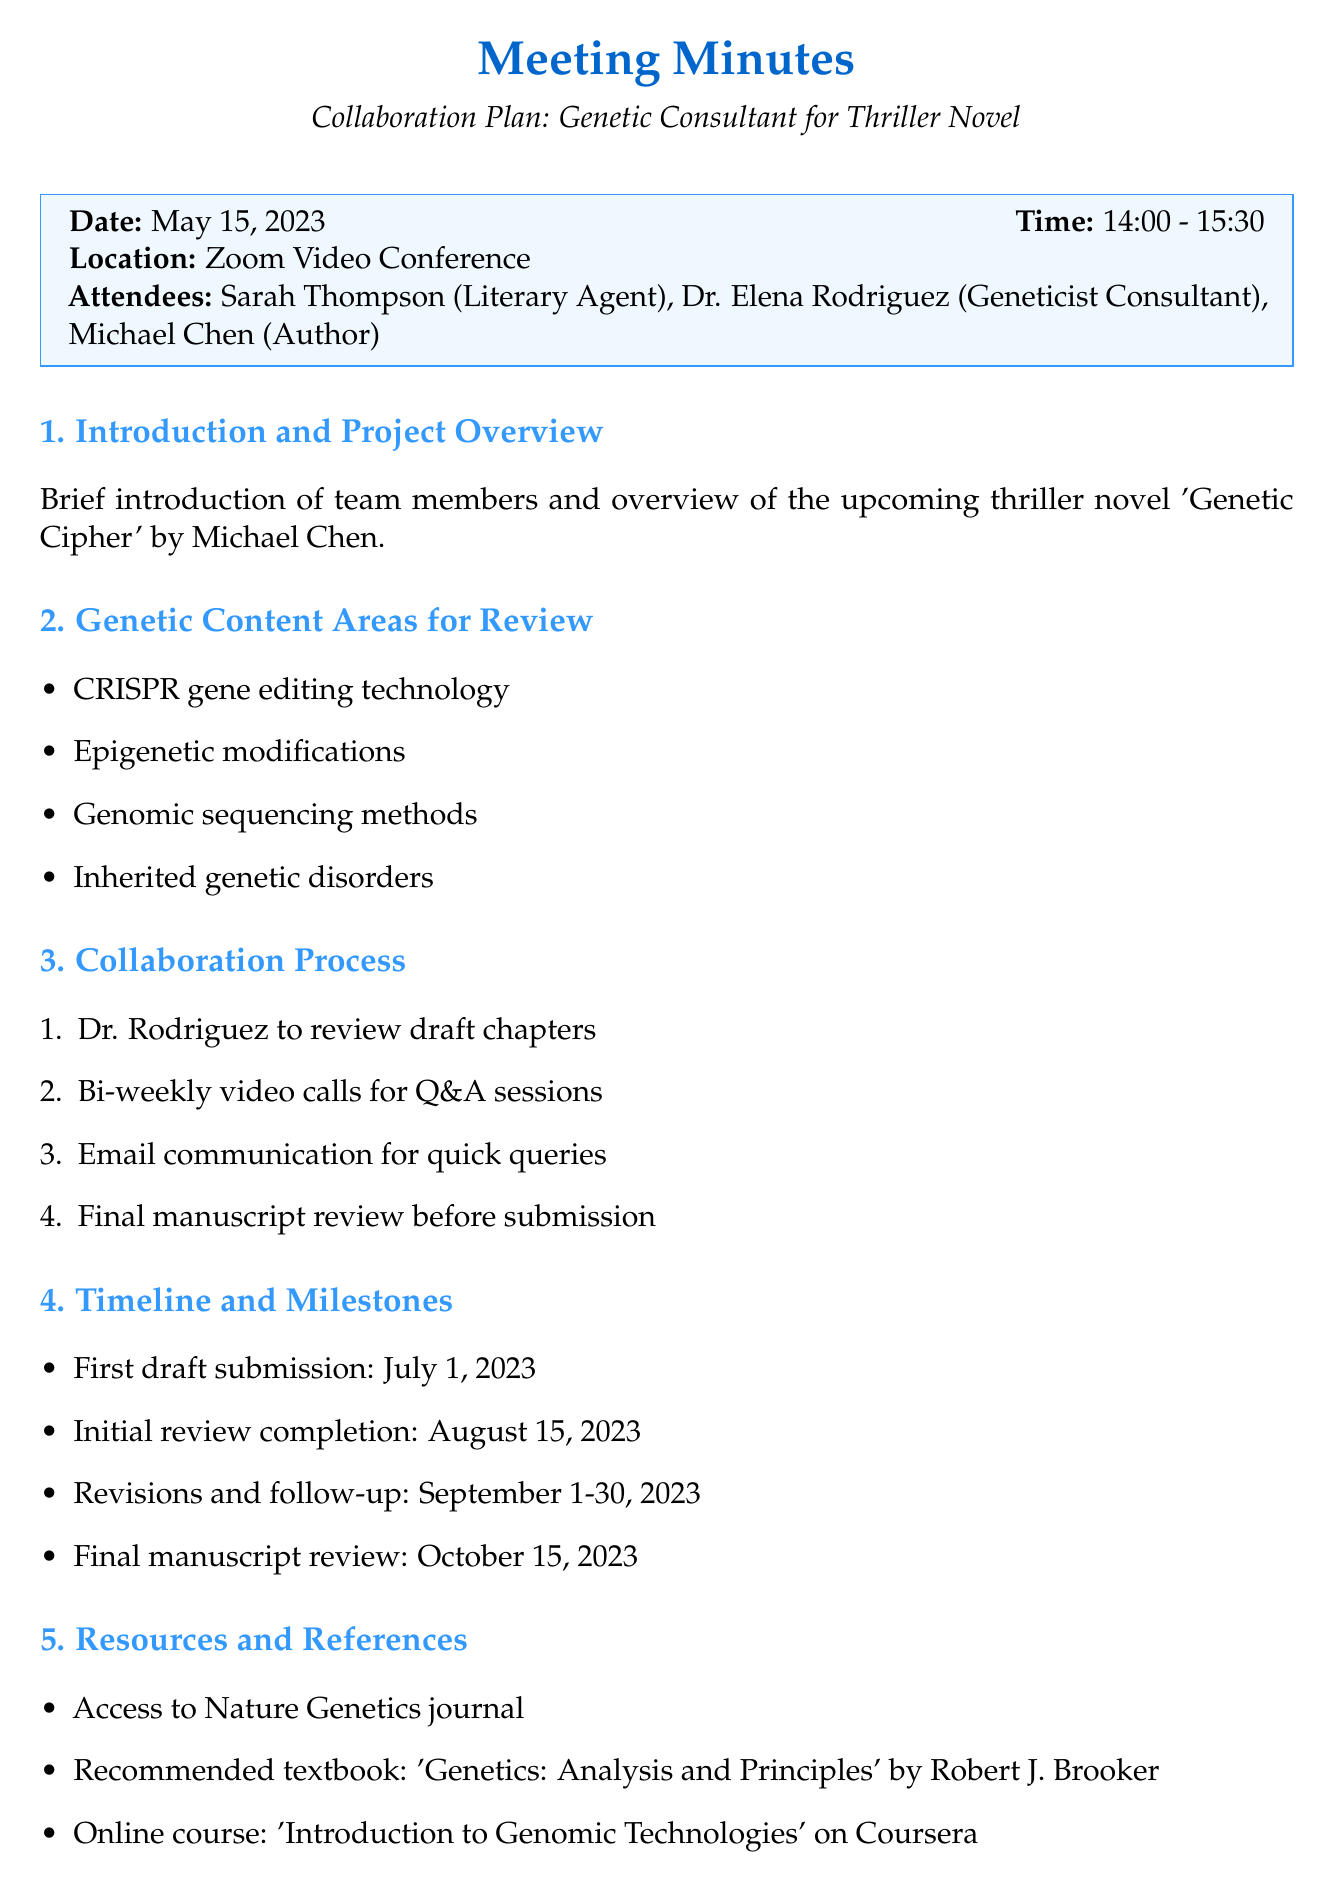What is the date of the meeting? The date of the meeting is explicitly stated in the document.
Answer: May 15, 2023 Who is the geneticist consultant involved? The document lists the attendees and identifies the geneticist consultant.
Answer: Dr. Elena Rodriguez What is the title of Michael Chen's upcoming novel? The overview section mentions the title of the novel.
Answer: Genetic Cipher When is the first draft submission due? The timeline section provides specific due dates for important milestones.
Answer: July 1, 2023 What is one of the genetic content areas for review? The document lists several areas to be reviewed, so any of those can answer this question.
Answer: CRISPR gene editing technology How often will video calls be held? The collaboration process outlines the frequency of scheduled calls.
Answer: Bi-weekly What textbook is recommended for references? The resources section points out specific materials to be used, including textbooks.
Answer: Genetics: Analysis and Principles What action is Sarah responsible for next? The next steps section outlines specific responsibilities for each attendee.
Answer: Finalize consulting agreement What is the final manuscript review date? The timeline provides a specific date for the final review process to be completed.
Answer: October 15, 2023 